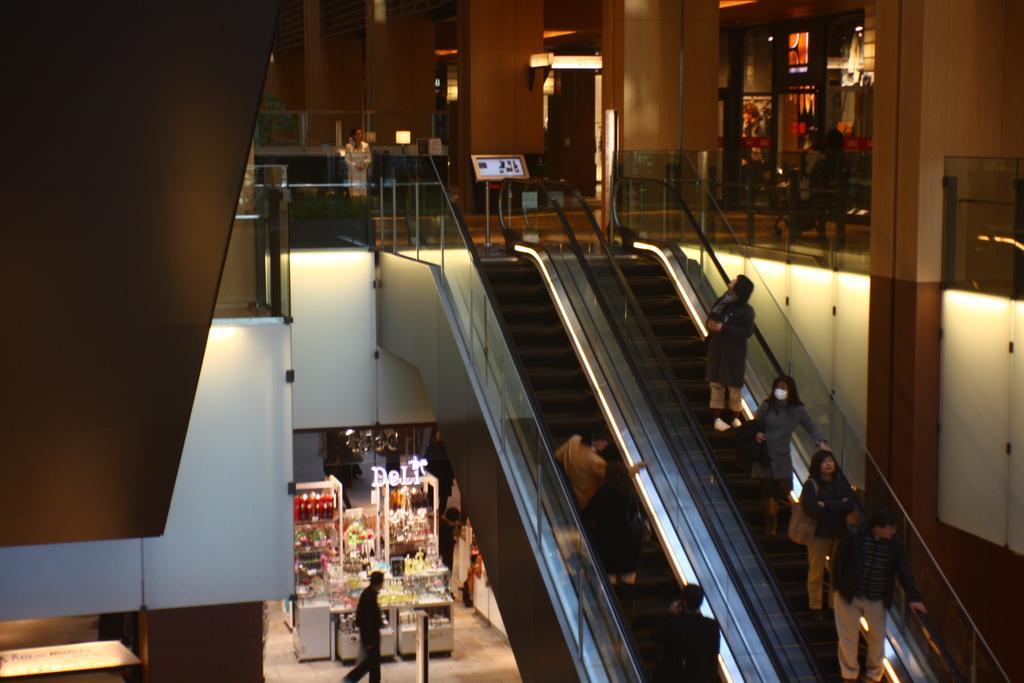Please provide a concise description of this image. In the center of the image we can see a few people are standing on the escalators. In the background there is a wall, pillars, lights, products, few people and a few other objects. 